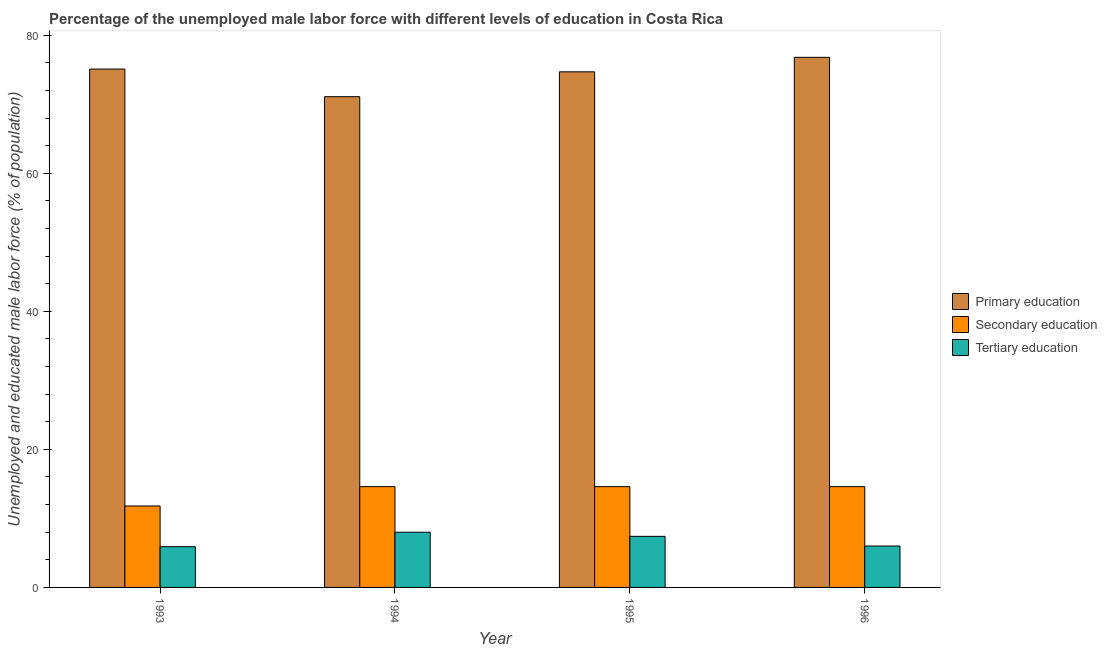How many different coloured bars are there?
Offer a terse response. 3. Are the number of bars per tick equal to the number of legend labels?
Ensure brevity in your answer.  Yes. What is the label of the 4th group of bars from the left?
Make the answer very short. 1996. What is the percentage of male labor force who received secondary education in 1994?
Give a very brief answer. 14.6. Across all years, what is the maximum percentage of male labor force who received secondary education?
Keep it short and to the point. 14.6. Across all years, what is the minimum percentage of male labor force who received primary education?
Keep it short and to the point. 71.1. In which year was the percentage of male labor force who received primary education maximum?
Offer a terse response. 1996. In which year was the percentage of male labor force who received tertiary education minimum?
Your answer should be compact. 1993. What is the total percentage of male labor force who received primary education in the graph?
Provide a short and direct response. 297.7. What is the difference between the percentage of male labor force who received primary education in 1993 and that in 1994?
Provide a short and direct response. 4. What is the difference between the percentage of male labor force who received secondary education in 1994 and the percentage of male labor force who received primary education in 1995?
Offer a terse response. 0. What is the average percentage of male labor force who received primary education per year?
Make the answer very short. 74.42. In the year 1995, what is the difference between the percentage of male labor force who received tertiary education and percentage of male labor force who received secondary education?
Make the answer very short. 0. What is the ratio of the percentage of male labor force who received primary education in 1994 to that in 1996?
Provide a short and direct response. 0.93. What is the difference between the highest and the lowest percentage of male labor force who received primary education?
Your answer should be compact. 5.7. In how many years, is the percentage of male labor force who received tertiary education greater than the average percentage of male labor force who received tertiary education taken over all years?
Provide a short and direct response. 2. What does the 1st bar from the left in 1994 represents?
Offer a very short reply. Primary education. What does the 3rd bar from the right in 1995 represents?
Provide a succinct answer. Primary education. How many bars are there?
Ensure brevity in your answer.  12. What is the difference between two consecutive major ticks on the Y-axis?
Offer a terse response. 20. Are the values on the major ticks of Y-axis written in scientific E-notation?
Make the answer very short. No. Does the graph contain any zero values?
Your answer should be very brief. No. Does the graph contain grids?
Provide a short and direct response. No. Where does the legend appear in the graph?
Make the answer very short. Center right. How many legend labels are there?
Give a very brief answer. 3. What is the title of the graph?
Provide a short and direct response. Percentage of the unemployed male labor force with different levels of education in Costa Rica. Does "Male employers" appear as one of the legend labels in the graph?
Your answer should be very brief. No. What is the label or title of the Y-axis?
Provide a succinct answer. Unemployed and educated male labor force (% of population). What is the Unemployed and educated male labor force (% of population) in Primary education in 1993?
Make the answer very short. 75.1. What is the Unemployed and educated male labor force (% of population) in Secondary education in 1993?
Your answer should be very brief. 11.8. What is the Unemployed and educated male labor force (% of population) in Tertiary education in 1993?
Ensure brevity in your answer.  5.9. What is the Unemployed and educated male labor force (% of population) of Primary education in 1994?
Make the answer very short. 71.1. What is the Unemployed and educated male labor force (% of population) in Secondary education in 1994?
Your answer should be very brief. 14.6. What is the Unemployed and educated male labor force (% of population) in Tertiary education in 1994?
Provide a succinct answer. 8. What is the Unemployed and educated male labor force (% of population) in Primary education in 1995?
Make the answer very short. 74.7. What is the Unemployed and educated male labor force (% of population) in Secondary education in 1995?
Your answer should be very brief. 14.6. What is the Unemployed and educated male labor force (% of population) in Tertiary education in 1995?
Keep it short and to the point. 7.4. What is the Unemployed and educated male labor force (% of population) of Primary education in 1996?
Provide a succinct answer. 76.8. What is the Unemployed and educated male labor force (% of population) in Secondary education in 1996?
Make the answer very short. 14.6. What is the Unemployed and educated male labor force (% of population) of Tertiary education in 1996?
Your answer should be compact. 6. Across all years, what is the maximum Unemployed and educated male labor force (% of population) of Primary education?
Keep it short and to the point. 76.8. Across all years, what is the maximum Unemployed and educated male labor force (% of population) of Secondary education?
Give a very brief answer. 14.6. Across all years, what is the maximum Unemployed and educated male labor force (% of population) in Tertiary education?
Your answer should be very brief. 8. Across all years, what is the minimum Unemployed and educated male labor force (% of population) in Primary education?
Offer a very short reply. 71.1. Across all years, what is the minimum Unemployed and educated male labor force (% of population) of Secondary education?
Your response must be concise. 11.8. Across all years, what is the minimum Unemployed and educated male labor force (% of population) in Tertiary education?
Ensure brevity in your answer.  5.9. What is the total Unemployed and educated male labor force (% of population) in Primary education in the graph?
Provide a succinct answer. 297.7. What is the total Unemployed and educated male labor force (% of population) in Secondary education in the graph?
Ensure brevity in your answer.  55.6. What is the total Unemployed and educated male labor force (% of population) of Tertiary education in the graph?
Make the answer very short. 27.3. What is the difference between the Unemployed and educated male labor force (% of population) in Primary education in 1993 and that in 1994?
Your answer should be very brief. 4. What is the difference between the Unemployed and educated male labor force (% of population) in Secondary education in 1993 and that in 1994?
Offer a terse response. -2.8. What is the difference between the Unemployed and educated male labor force (% of population) in Primary education in 1993 and that in 1995?
Your response must be concise. 0.4. What is the difference between the Unemployed and educated male labor force (% of population) of Primary education in 1993 and that in 1996?
Offer a very short reply. -1.7. What is the difference between the Unemployed and educated male labor force (% of population) of Tertiary education in 1993 and that in 1996?
Ensure brevity in your answer.  -0.1. What is the difference between the Unemployed and educated male labor force (% of population) in Primary education in 1994 and that in 1995?
Provide a short and direct response. -3.6. What is the difference between the Unemployed and educated male labor force (% of population) of Secondary education in 1994 and that in 1995?
Provide a succinct answer. 0. What is the difference between the Unemployed and educated male labor force (% of population) in Tertiary education in 1995 and that in 1996?
Give a very brief answer. 1.4. What is the difference between the Unemployed and educated male labor force (% of population) of Primary education in 1993 and the Unemployed and educated male labor force (% of population) of Secondary education in 1994?
Ensure brevity in your answer.  60.5. What is the difference between the Unemployed and educated male labor force (% of population) of Primary education in 1993 and the Unemployed and educated male labor force (% of population) of Tertiary education in 1994?
Your response must be concise. 67.1. What is the difference between the Unemployed and educated male labor force (% of population) of Secondary education in 1993 and the Unemployed and educated male labor force (% of population) of Tertiary education in 1994?
Offer a very short reply. 3.8. What is the difference between the Unemployed and educated male labor force (% of population) of Primary education in 1993 and the Unemployed and educated male labor force (% of population) of Secondary education in 1995?
Offer a terse response. 60.5. What is the difference between the Unemployed and educated male labor force (% of population) of Primary education in 1993 and the Unemployed and educated male labor force (% of population) of Tertiary education in 1995?
Keep it short and to the point. 67.7. What is the difference between the Unemployed and educated male labor force (% of population) in Primary education in 1993 and the Unemployed and educated male labor force (% of population) in Secondary education in 1996?
Keep it short and to the point. 60.5. What is the difference between the Unemployed and educated male labor force (% of population) in Primary education in 1993 and the Unemployed and educated male labor force (% of population) in Tertiary education in 1996?
Make the answer very short. 69.1. What is the difference between the Unemployed and educated male labor force (% of population) in Primary education in 1994 and the Unemployed and educated male labor force (% of population) in Secondary education in 1995?
Provide a short and direct response. 56.5. What is the difference between the Unemployed and educated male labor force (% of population) of Primary education in 1994 and the Unemployed and educated male labor force (% of population) of Tertiary education in 1995?
Provide a short and direct response. 63.7. What is the difference between the Unemployed and educated male labor force (% of population) of Secondary education in 1994 and the Unemployed and educated male labor force (% of population) of Tertiary education in 1995?
Offer a very short reply. 7.2. What is the difference between the Unemployed and educated male labor force (% of population) in Primary education in 1994 and the Unemployed and educated male labor force (% of population) in Secondary education in 1996?
Your response must be concise. 56.5. What is the difference between the Unemployed and educated male labor force (% of population) in Primary education in 1994 and the Unemployed and educated male labor force (% of population) in Tertiary education in 1996?
Ensure brevity in your answer.  65.1. What is the difference between the Unemployed and educated male labor force (% of population) in Primary education in 1995 and the Unemployed and educated male labor force (% of population) in Secondary education in 1996?
Give a very brief answer. 60.1. What is the difference between the Unemployed and educated male labor force (% of population) of Primary education in 1995 and the Unemployed and educated male labor force (% of population) of Tertiary education in 1996?
Offer a terse response. 68.7. What is the difference between the Unemployed and educated male labor force (% of population) of Secondary education in 1995 and the Unemployed and educated male labor force (% of population) of Tertiary education in 1996?
Offer a very short reply. 8.6. What is the average Unemployed and educated male labor force (% of population) of Primary education per year?
Your answer should be very brief. 74.42. What is the average Unemployed and educated male labor force (% of population) of Tertiary education per year?
Your answer should be compact. 6.83. In the year 1993, what is the difference between the Unemployed and educated male labor force (% of population) in Primary education and Unemployed and educated male labor force (% of population) in Secondary education?
Make the answer very short. 63.3. In the year 1993, what is the difference between the Unemployed and educated male labor force (% of population) in Primary education and Unemployed and educated male labor force (% of population) in Tertiary education?
Provide a succinct answer. 69.2. In the year 1994, what is the difference between the Unemployed and educated male labor force (% of population) in Primary education and Unemployed and educated male labor force (% of population) in Secondary education?
Make the answer very short. 56.5. In the year 1994, what is the difference between the Unemployed and educated male labor force (% of population) in Primary education and Unemployed and educated male labor force (% of population) in Tertiary education?
Keep it short and to the point. 63.1. In the year 1994, what is the difference between the Unemployed and educated male labor force (% of population) in Secondary education and Unemployed and educated male labor force (% of population) in Tertiary education?
Make the answer very short. 6.6. In the year 1995, what is the difference between the Unemployed and educated male labor force (% of population) of Primary education and Unemployed and educated male labor force (% of population) of Secondary education?
Make the answer very short. 60.1. In the year 1995, what is the difference between the Unemployed and educated male labor force (% of population) in Primary education and Unemployed and educated male labor force (% of population) in Tertiary education?
Offer a very short reply. 67.3. In the year 1995, what is the difference between the Unemployed and educated male labor force (% of population) in Secondary education and Unemployed and educated male labor force (% of population) in Tertiary education?
Your response must be concise. 7.2. In the year 1996, what is the difference between the Unemployed and educated male labor force (% of population) of Primary education and Unemployed and educated male labor force (% of population) of Secondary education?
Make the answer very short. 62.2. In the year 1996, what is the difference between the Unemployed and educated male labor force (% of population) in Primary education and Unemployed and educated male labor force (% of population) in Tertiary education?
Your answer should be very brief. 70.8. In the year 1996, what is the difference between the Unemployed and educated male labor force (% of population) of Secondary education and Unemployed and educated male labor force (% of population) of Tertiary education?
Make the answer very short. 8.6. What is the ratio of the Unemployed and educated male labor force (% of population) of Primary education in 1993 to that in 1994?
Offer a very short reply. 1.06. What is the ratio of the Unemployed and educated male labor force (% of population) in Secondary education in 1993 to that in 1994?
Give a very brief answer. 0.81. What is the ratio of the Unemployed and educated male labor force (% of population) in Tertiary education in 1993 to that in 1994?
Provide a short and direct response. 0.74. What is the ratio of the Unemployed and educated male labor force (% of population) in Primary education in 1993 to that in 1995?
Provide a short and direct response. 1.01. What is the ratio of the Unemployed and educated male labor force (% of population) in Secondary education in 1993 to that in 1995?
Your response must be concise. 0.81. What is the ratio of the Unemployed and educated male labor force (% of population) in Tertiary education in 1993 to that in 1995?
Offer a very short reply. 0.8. What is the ratio of the Unemployed and educated male labor force (% of population) in Primary education in 1993 to that in 1996?
Make the answer very short. 0.98. What is the ratio of the Unemployed and educated male labor force (% of population) of Secondary education in 1993 to that in 1996?
Ensure brevity in your answer.  0.81. What is the ratio of the Unemployed and educated male labor force (% of population) in Tertiary education in 1993 to that in 1996?
Provide a short and direct response. 0.98. What is the ratio of the Unemployed and educated male labor force (% of population) of Primary education in 1994 to that in 1995?
Ensure brevity in your answer.  0.95. What is the ratio of the Unemployed and educated male labor force (% of population) in Tertiary education in 1994 to that in 1995?
Provide a succinct answer. 1.08. What is the ratio of the Unemployed and educated male labor force (% of population) of Primary education in 1994 to that in 1996?
Your answer should be very brief. 0.93. What is the ratio of the Unemployed and educated male labor force (% of population) in Tertiary education in 1994 to that in 1996?
Your answer should be very brief. 1.33. What is the ratio of the Unemployed and educated male labor force (% of population) in Primary education in 1995 to that in 1996?
Provide a succinct answer. 0.97. What is the ratio of the Unemployed and educated male labor force (% of population) of Secondary education in 1995 to that in 1996?
Provide a succinct answer. 1. What is the ratio of the Unemployed and educated male labor force (% of population) in Tertiary education in 1995 to that in 1996?
Make the answer very short. 1.23. What is the difference between the highest and the second highest Unemployed and educated male labor force (% of population) of Secondary education?
Give a very brief answer. 0. What is the difference between the highest and the lowest Unemployed and educated male labor force (% of population) of Primary education?
Give a very brief answer. 5.7. What is the difference between the highest and the lowest Unemployed and educated male labor force (% of population) of Tertiary education?
Keep it short and to the point. 2.1. 